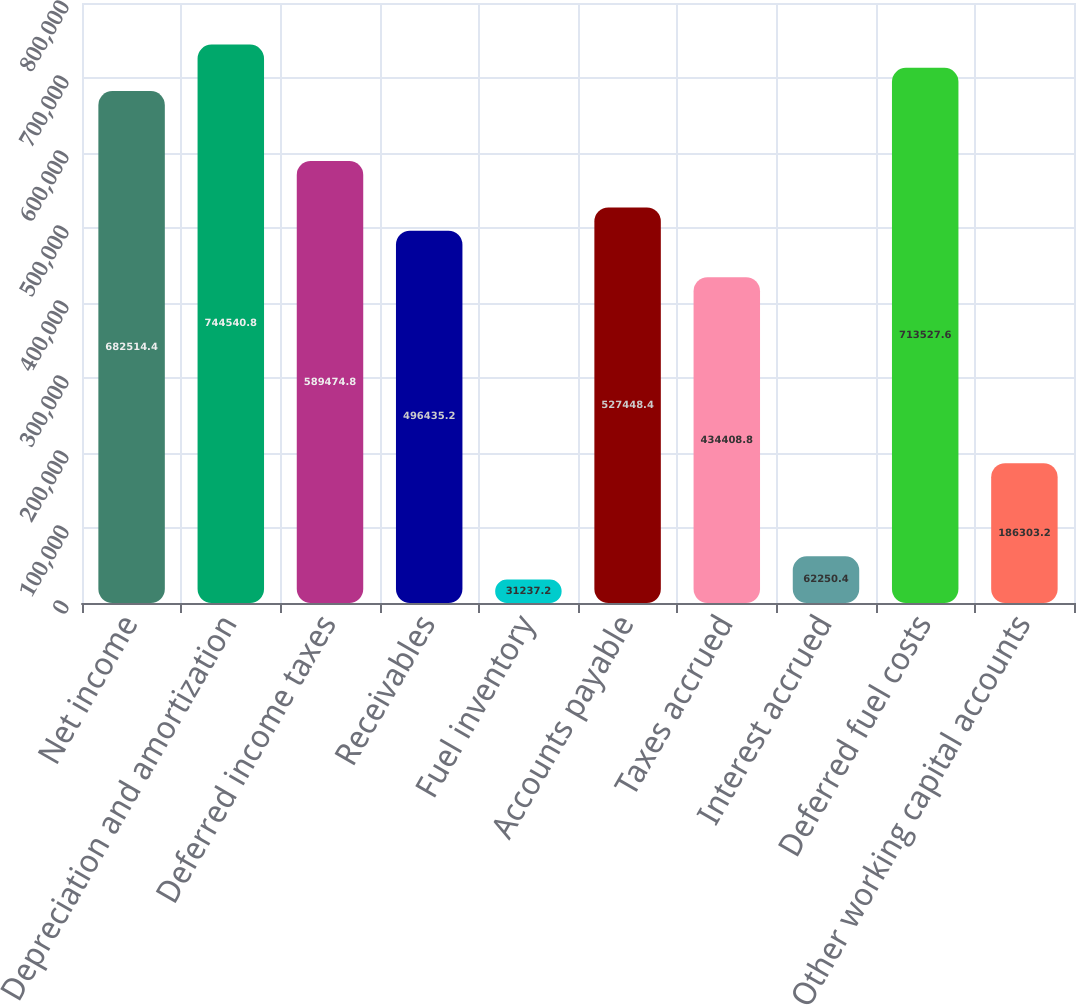Convert chart. <chart><loc_0><loc_0><loc_500><loc_500><bar_chart><fcel>Net income<fcel>Depreciation and amortization<fcel>Deferred income taxes<fcel>Receivables<fcel>Fuel inventory<fcel>Accounts payable<fcel>Taxes accrued<fcel>Interest accrued<fcel>Deferred fuel costs<fcel>Other working capital accounts<nl><fcel>682514<fcel>744541<fcel>589475<fcel>496435<fcel>31237.2<fcel>527448<fcel>434409<fcel>62250.4<fcel>713528<fcel>186303<nl></chart> 